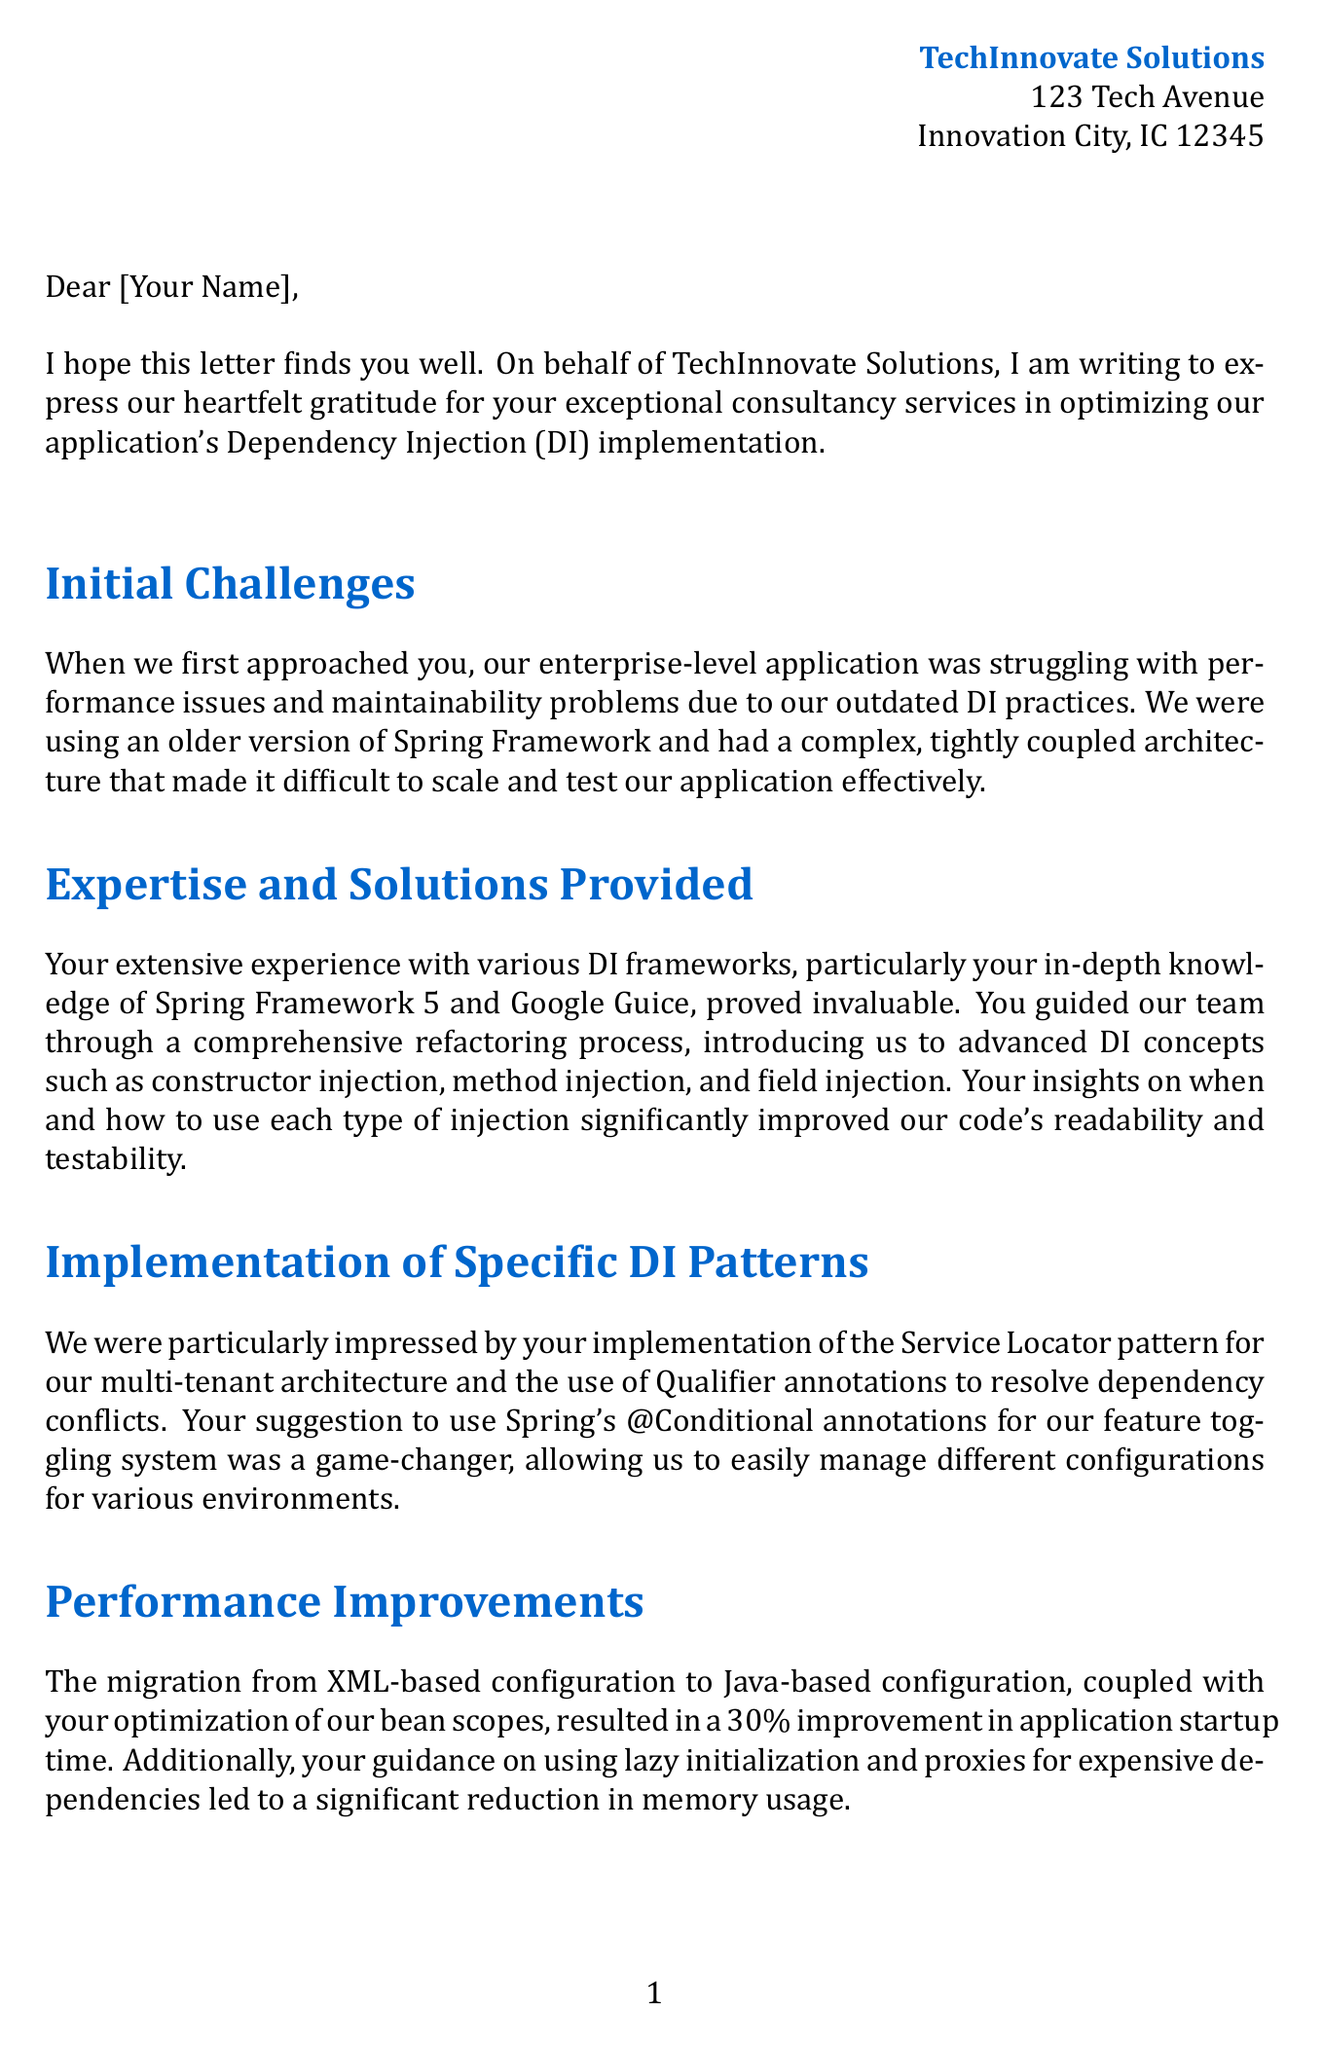what is the name of the company expressing gratitude? The document mentions TechInnovate Solutions as the company providing gratitude for the consultancy services.
Answer: TechInnovate Solutions who is the CTO of the company? The signature in the letter indicates that Emily Chen is the CTO of TechInnovate Solutions.
Answer: Emily Chen what is the percentage improvement in application startup time? The letter states that there was a 30% improvement in application startup time due to the changes made.
Answer: 30% how many developers were on the team? The document specifies that the team size was over 50 developers working on the project.
Answer: 50+ which Dependency Injection framework was upgraded to? The letter indicates that the application was upgraded to Spring Framework 5.3.
Answer: Spring Framework 5.3 what percentage increase in unit test coverage was achieved? The letter mentions a 40% increase in unit test coverage following the consultancy services.
Answer: 40% which two types of injection were introduced to the team? The letter highlights constructor injection and method injection as two types of injection that were introduced.
Answer: constructor injection, method injection what was the duration of the consultancy project? The document states that the duration of the project was 3 months.
Answer: 3 months what was a key concept implemented for resolving dependency conflicts? The implementation of Qualifier annotations was a key concept for resolving dependency conflicts.
Answer: Qualifier annotations 